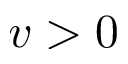Convert formula to latex. <formula><loc_0><loc_0><loc_500><loc_500>v > 0</formula> 